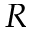<formula> <loc_0><loc_0><loc_500><loc_500>R</formula> 